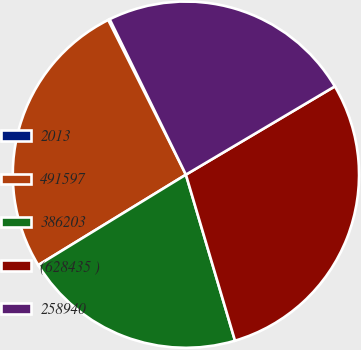Convert chart. <chart><loc_0><loc_0><loc_500><loc_500><pie_chart><fcel>2013<fcel>491597<fcel>386203<fcel>(628435 )<fcel>258940<nl><fcel>0.15%<fcel>26.34%<fcel>20.83%<fcel>28.94%<fcel>23.74%<nl></chart> 